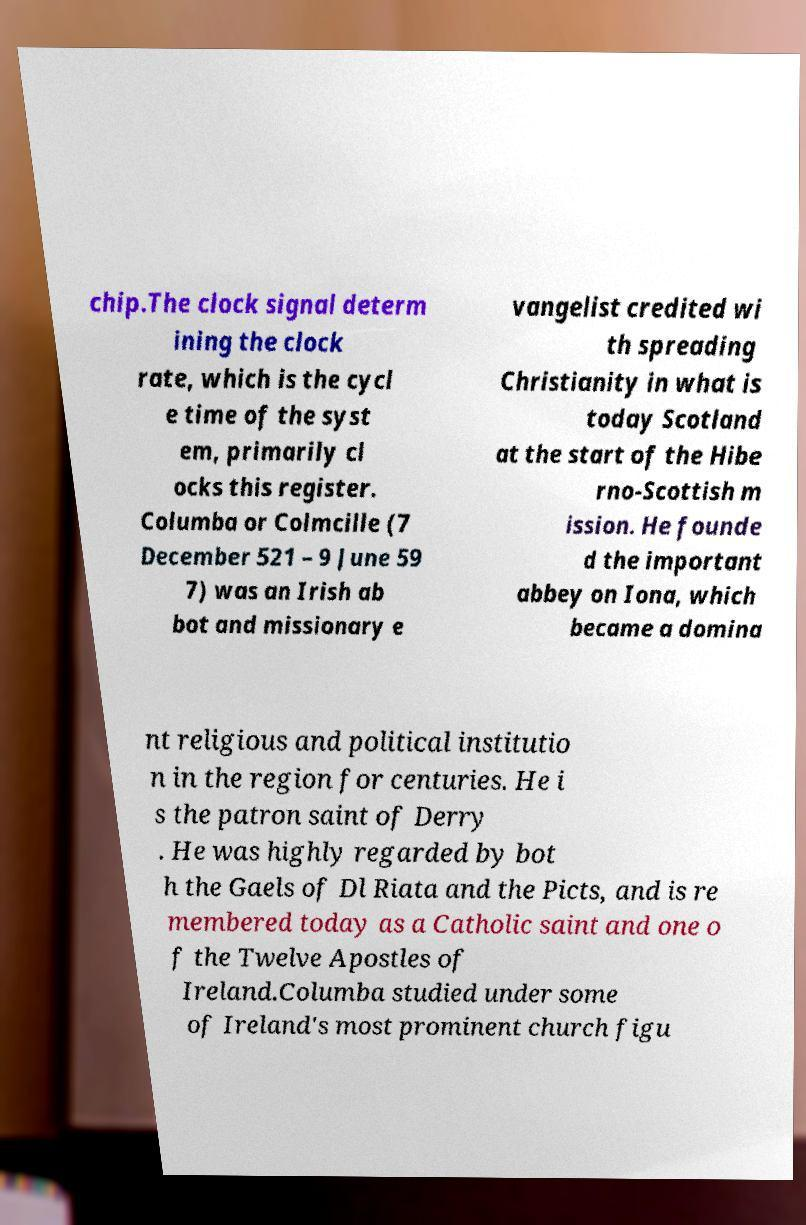Can you accurately transcribe the text from the provided image for me? chip.The clock signal determ ining the clock rate, which is the cycl e time of the syst em, primarily cl ocks this register. Columba or Colmcille (7 December 521 – 9 June 59 7) was an Irish ab bot and missionary e vangelist credited wi th spreading Christianity in what is today Scotland at the start of the Hibe rno-Scottish m ission. He founde d the important abbey on Iona, which became a domina nt religious and political institutio n in the region for centuries. He i s the patron saint of Derry . He was highly regarded by bot h the Gaels of Dl Riata and the Picts, and is re membered today as a Catholic saint and one o f the Twelve Apostles of Ireland.Columba studied under some of Ireland's most prominent church figu 